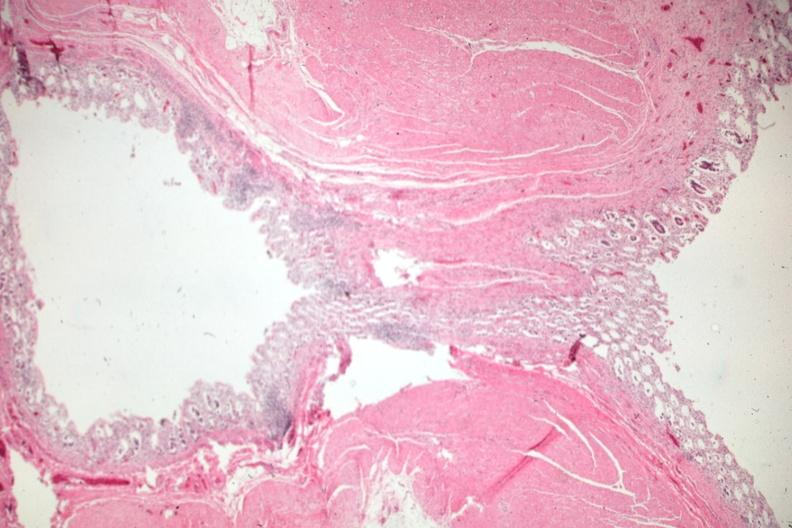s optic nerve present?
Answer the question using a single word or phrase. No 